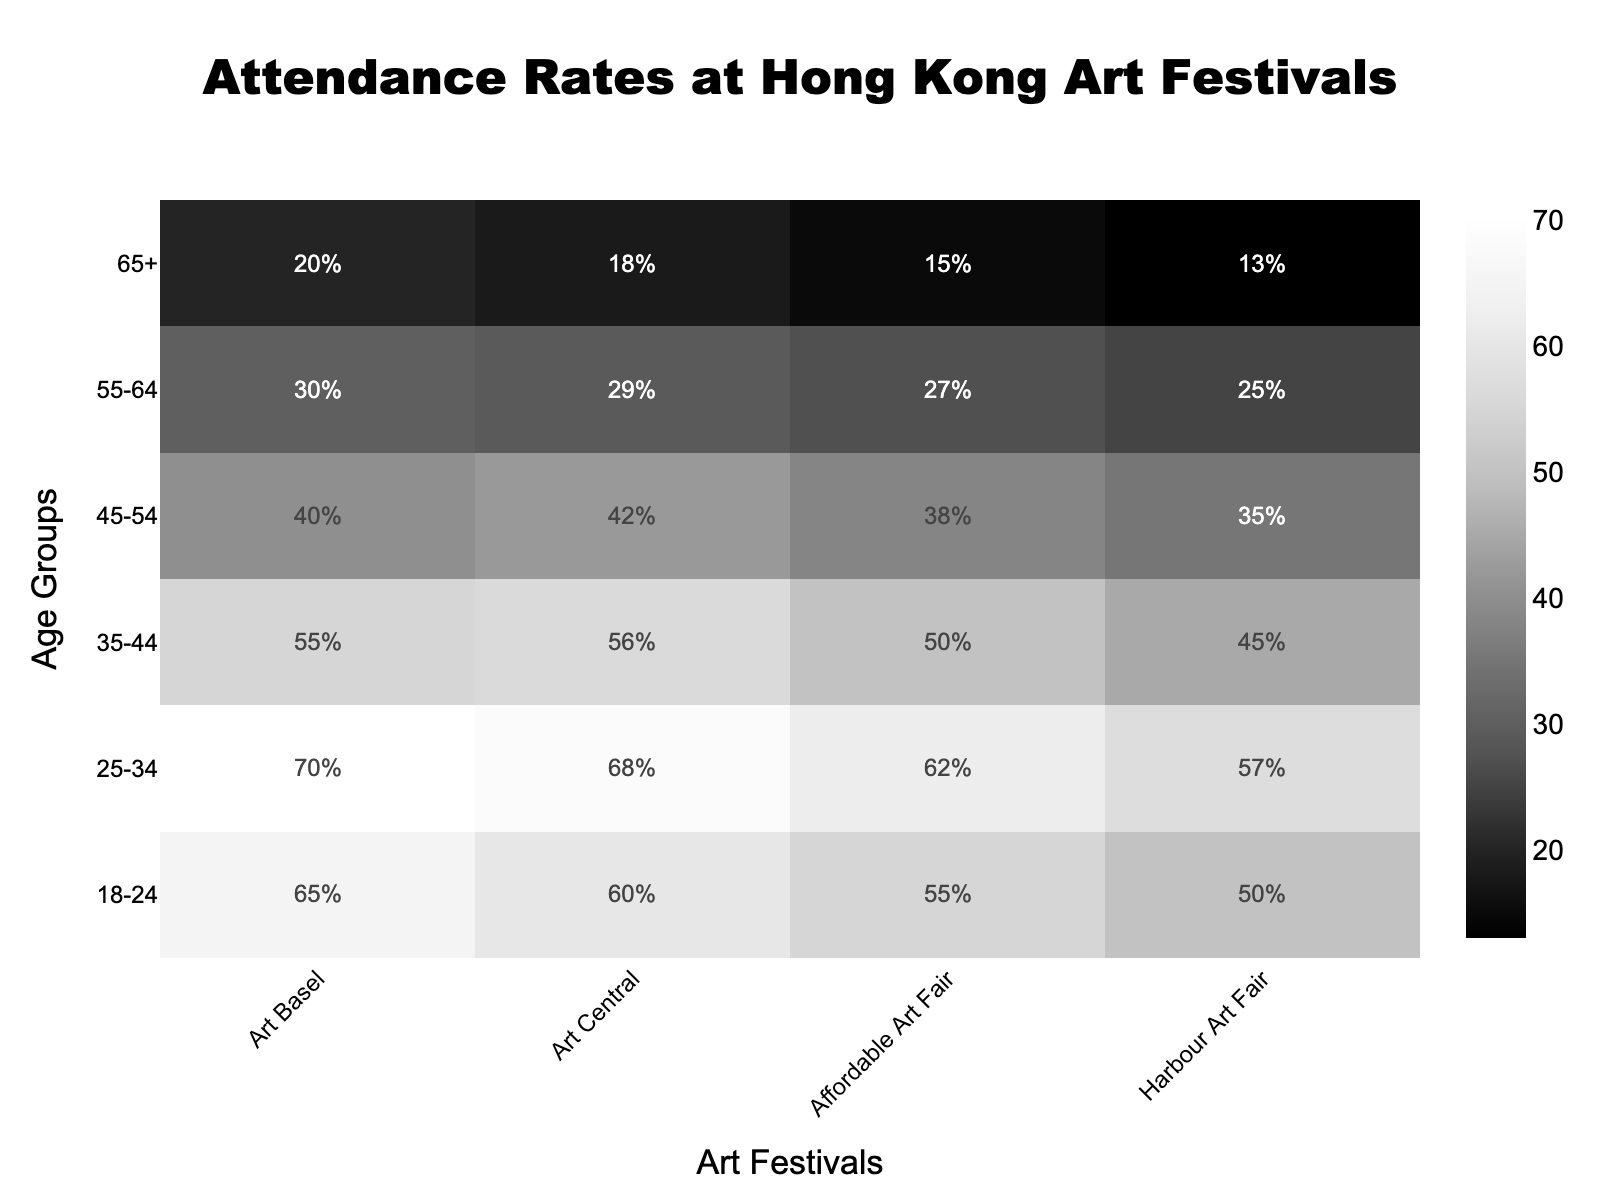What's the title of the heatmap? The title of a heatmap is usually located at the top of the figure. In this case, the title "Attendance Rates at Hong Kong Art Festivals" is clearly stated at the top.
Answer: Attendance Rates at Hong Kong Art Festivals What are the age groups represented on the y-axis? The y-axis lists the age groups in the dataset. By looking at the figure, you can see the age groups are 18-24, 25-34, 35-44, 45-54, 55-64, and 65+.
Answer: 18-24, 25-34, 35-44, 45-54, 55-64, 65+ Which art festival has the highest attendance rate among the 25-34 age group? Find the 25-34 age group on the y-axis and look across the row for the art festivals on the x-axis. The highest attendance rate for the 25-34 age group is at Art Basel with 70%.
Answer: Art Basel How does the attendance rate change from the 18-24 age group to the 65+ age group for Art Central? Compare the attendance rates for Art Central across the age groups from 18-24 to 65+. The values are 60%, 68%, 56%, 42%, 29%, and 18%, respectively.
Answer: Decreases What is the average attendance rate for the 45-54 age group across all festivals? Sum the attendance rates for the 45-54 age group across all festivals: 40% (Art Basel) + 42% (Art Central) + 38% (Affordable Art Fair) + 35% (Harbour Art Fair) = 155, then divide by 4 (the number of festivals), so 155 / 4 = 38.75.
Answer: 38.75% Which age group has the lowest attendance rate at the Harbour Art Fair? Find the Harbour Art Fair column and look for the lowest value across the age groups. The lowest attendance rate is 13% for the 65+ age group.
Answer: 65+ Compare the attendance rates between Art Basel and Affordable Art Fair for the 35-44 age group. Which festival has a higher rate? For the 35-44 age group, compare the values: Art Basel has 55%, and Affordable Art Fair has 50%. Art Basel has a higher rate.
Answer: Art Basel What is the difference in attendance rate between the festivals with the highest and lowest attendance rates for the 18-24 age group? Find the highest and lowest rates for the 18-24 age group: Art Basel has 65%, and Harbour Art Fair has 50%. The difference is 65% - 50% = 15%.
Answer: 15% Identify the festival with the most consistent attendance rate across all age groups. To determine consistency, look for the festival with the smallest variation in attendance rates across age groups. Art Basel’s rates are 65%, 70%, 55%, 40%, 30%, and 20%. Affordable Art Fair’s rates are 55%, 62%, 50%, 38%, 27%, and 15%. Comparing these, Affordable Art Fair shows less variation among the rates.
Answer: Affordable Art Fair 